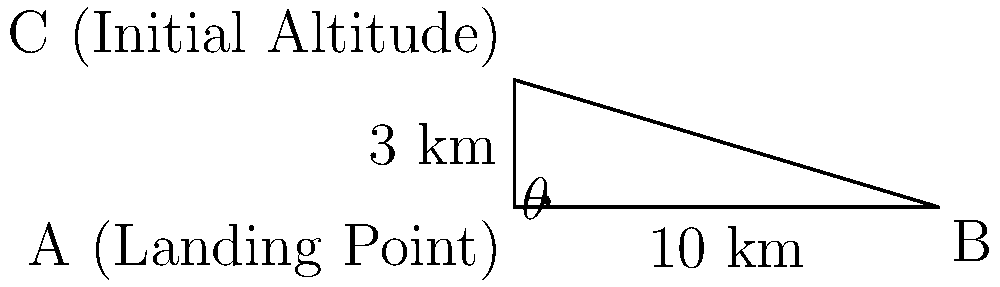As a glider pilot, you're preparing for a landing approach. Your glider is currently at an altitude of 3 km, and the landing point is 10 km away horizontally. Calculate the angle of descent ($\theta$) required for a straight-line approach to the landing point. Round your answer to the nearest degree. To solve this problem, we'll use basic trigonometry:

1) First, visualize the situation as a right-angled triangle:
   - The vertical side represents the altitude (3 km)
   - The horizontal side represents the distance to the landing point (10 km)
   - The hypotenuse represents the glider's path
   - The angle we're looking for ($\theta$) is between the horizontal and the hypotenuse

2) We can use the tangent function to find this angle:

   $\tan(\theta) = \frac{\text{opposite}}{\text{adjacent}} = \frac{\text{altitude}}{\text{distance}}$

3) Plugging in our values:

   $\tan(\theta) = \frac{3 \text{ km}}{10 \text{ km}} = 0.3$

4) To find $\theta$, we need to use the inverse tangent (arctan or $\tan^{-1}$):

   $\theta = \tan^{-1}(0.3)$

5) Using a calculator (or trigonometric tables):

   $\theta \approx 16.70^\circ$

6) Rounding to the nearest degree:

   $\theta \approx 17^\circ$

Therefore, the glider needs to descend at an angle of approximately 17 degrees to reach the landing point in a straight-line approach.
Answer: $17^\circ$ 